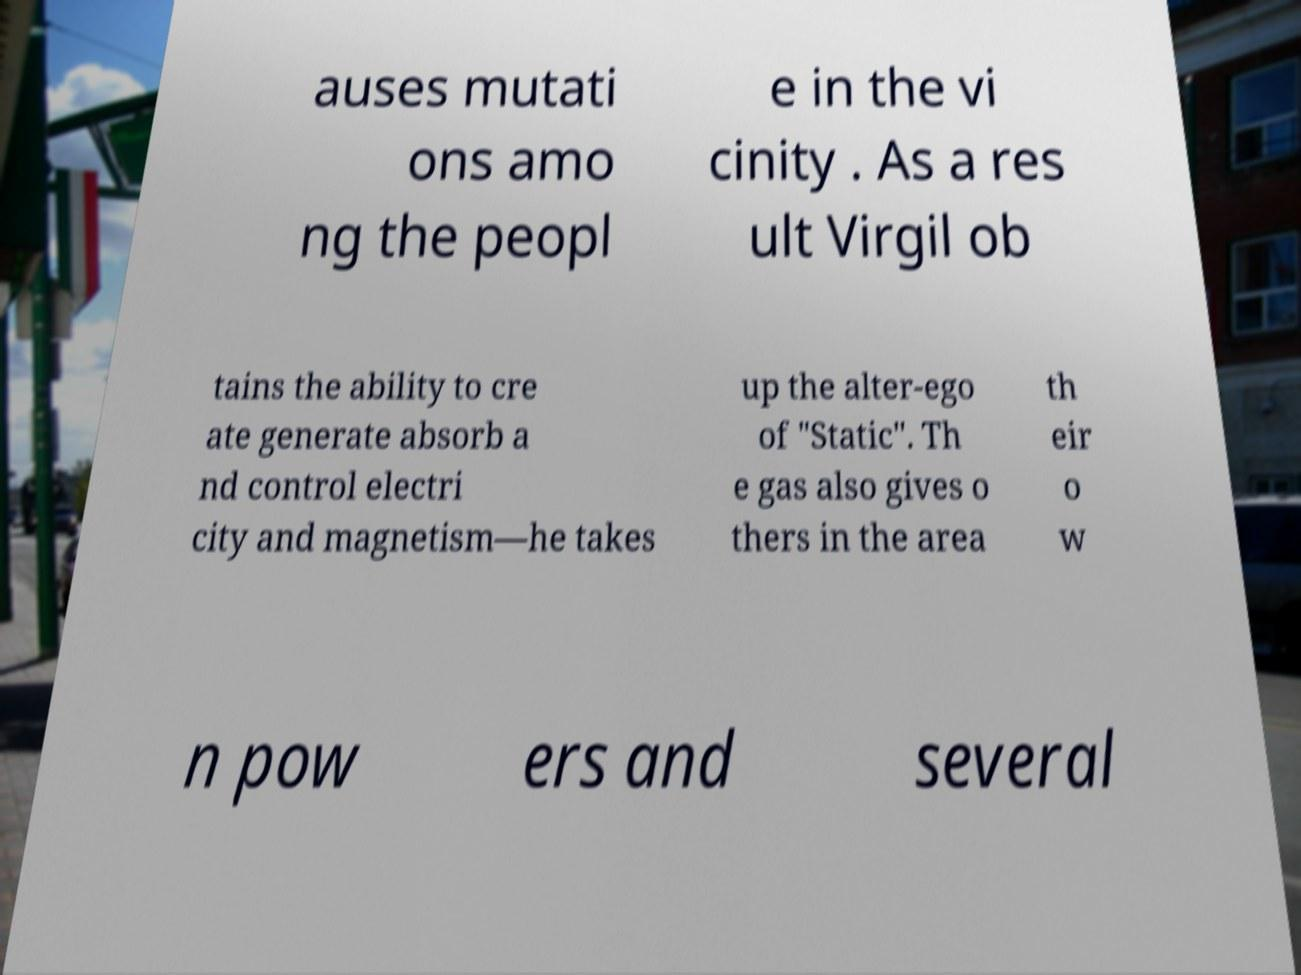There's text embedded in this image that I need extracted. Can you transcribe it verbatim? auses mutati ons amo ng the peopl e in the vi cinity . As a res ult Virgil ob tains the ability to cre ate generate absorb a nd control electri city and magnetism—he takes up the alter-ego of "Static". Th e gas also gives o thers in the area th eir o w n pow ers and several 